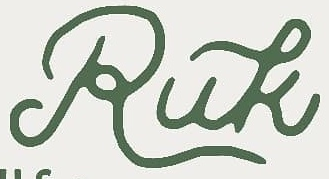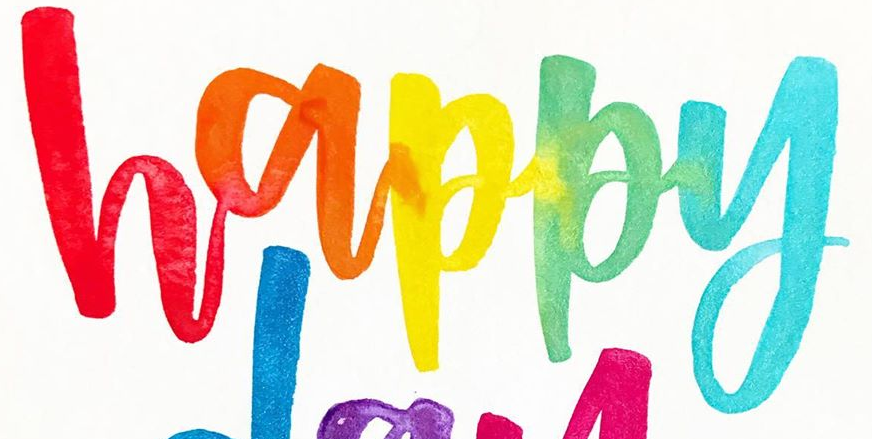Read the text content from these images in order, separated by a semicolon. Ruk; happy 